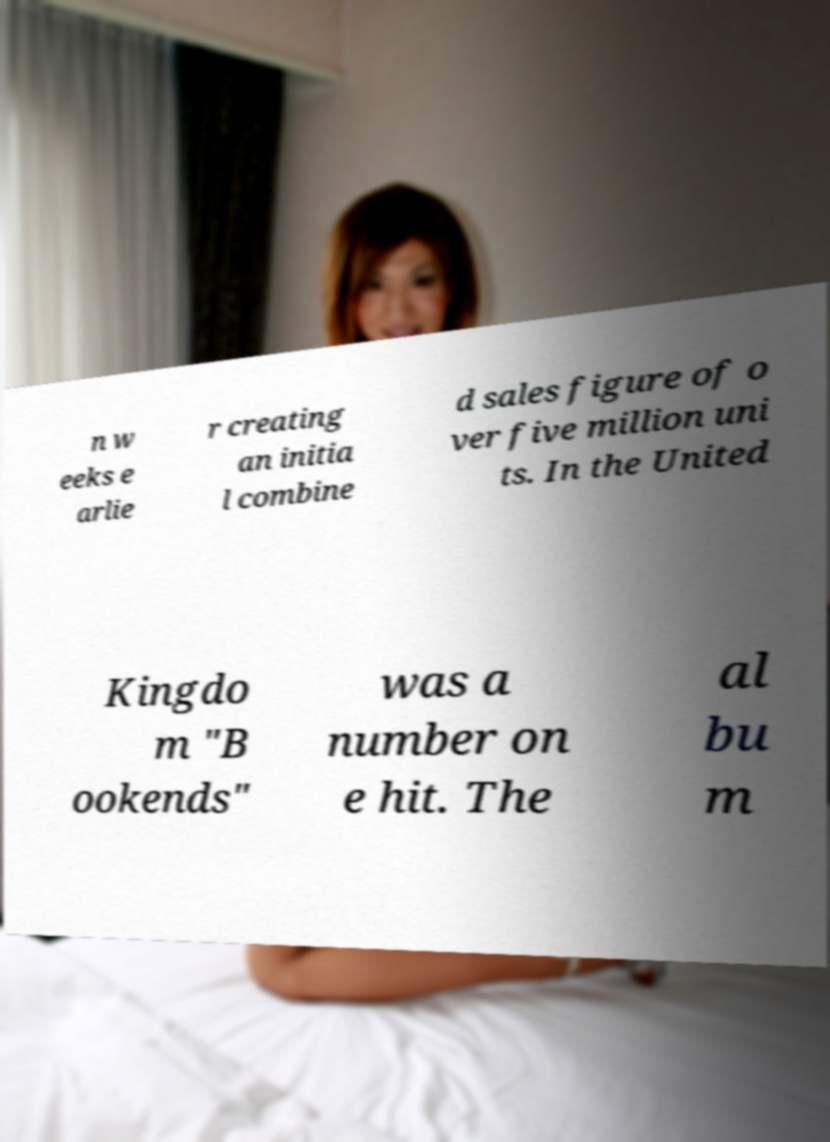What messages or text are displayed in this image? I need them in a readable, typed format. n w eeks e arlie r creating an initia l combine d sales figure of o ver five million uni ts. In the United Kingdo m "B ookends" was a number on e hit. The al bu m 